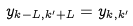<formula> <loc_0><loc_0><loc_500><loc_500>y _ { k - L , k ^ { \prime } + L } = y _ { k , k ^ { \prime } }</formula> 